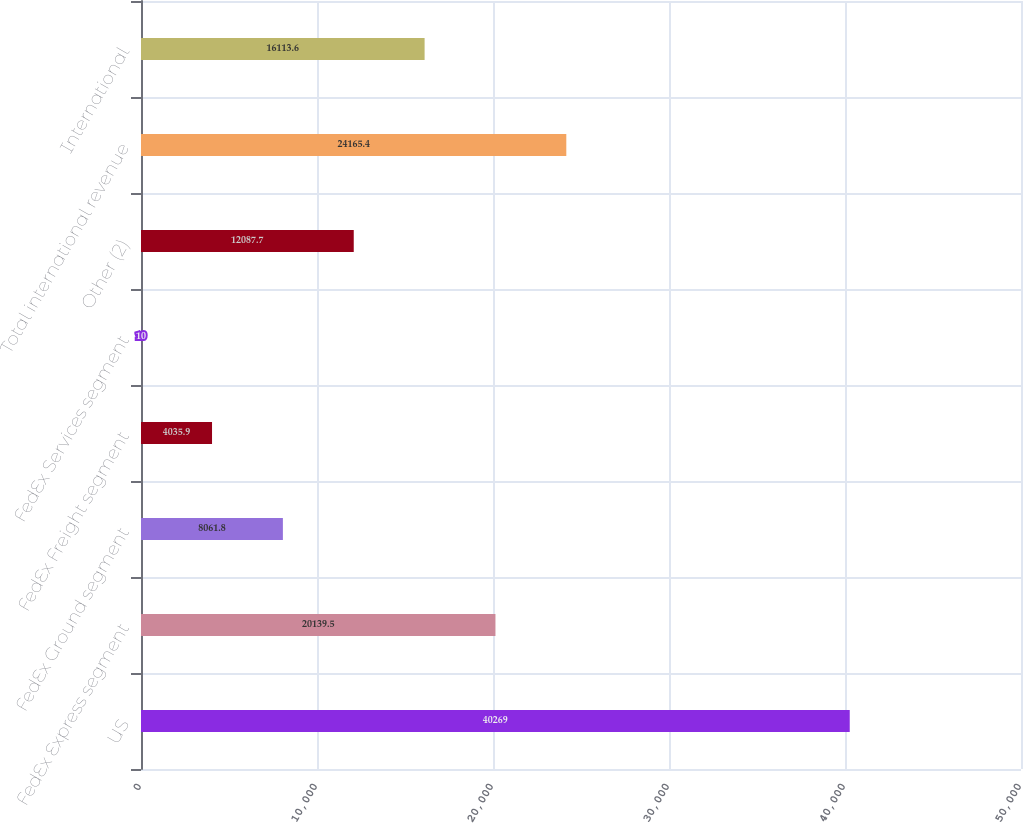Convert chart to OTSL. <chart><loc_0><loc_0><loc_500><loc_500><bar_chart><fcel>US<fcel>FedEx Express segment<fcel>FedEx Ground segment<fcel>FedEx Freight segment<fcel>FedEx Services segment<fcel>Other (2)<fcel>Total international revenue<fcel>International<nl><fcel>40269<fcel>20139.5<fcel>8061.8<fcel>4035.9<fcel>10<fcel>12087.7<fcel>24165.4<fcel>16113.6<nl></chart> 